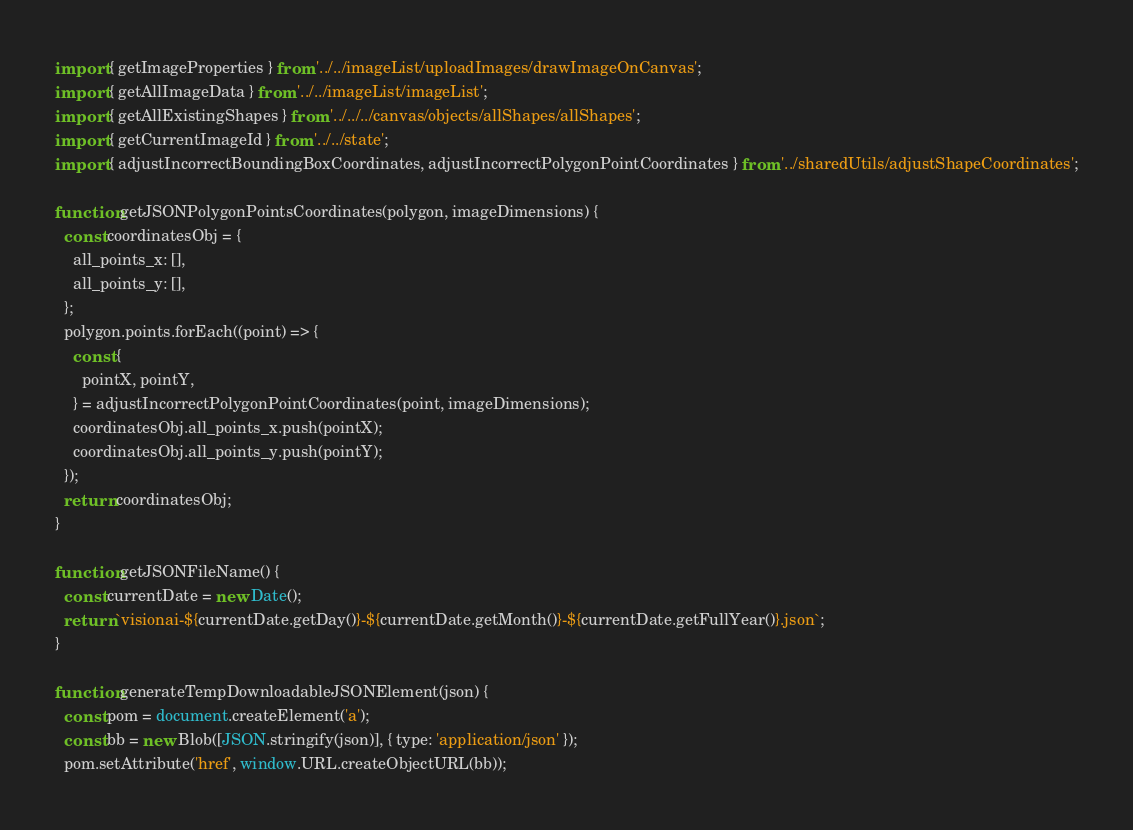<code> <loc_0><loc_0><loc_500><loc_500><_JavaScript_>import { getImageProperties } from '../../imageList/uploadImages/drawImageOnCanvas';
import { getAllImageData } from '../../imageList/imageList';
import { getAllExistingShapes } from '../../../canvas/objects/allShapes/allShapes';
import { getCurrentImageId } from '../../state';
import { adjustIncorrectBoundingBoxCoordinates, adjustIncorrectPolygonPointCoordinates } from '../sharedUtils/adjustShapeCoordinates';

function getJSONPolygonPointsCoordinates(polygon, imageDimensions) {
  const coordinatesObj = {
    all_points_x: [],
    all_points_y: [],
  };
  polygon.points.forEach((point) => {
    const {
      pointX, pointY,
    } = adjustIncorrectPolygonPointCoordinates(point, imageDimensions);
    coordinatesObj.all_points_x.push(pointX);
    coordinatesObj.all_points_y.push(pointY);
  });
  return coordinatesObj;
}

function getJSONFileName() {
  const currentDate = new Date();
  return `visionai-${currentDate.getDay()}-${currentDate.getMonth()}-${currentDate.getFullYear()}.json`;
}

function generateTempDownloadableJSONElement(json) {
  const pom = document.createElement('a');
  const bb = new Blob([JSON.stringify(json)], { type: 'application/json' });
  pom.setAttribute('href', window.URL.createObjectURL(bb));</code> 